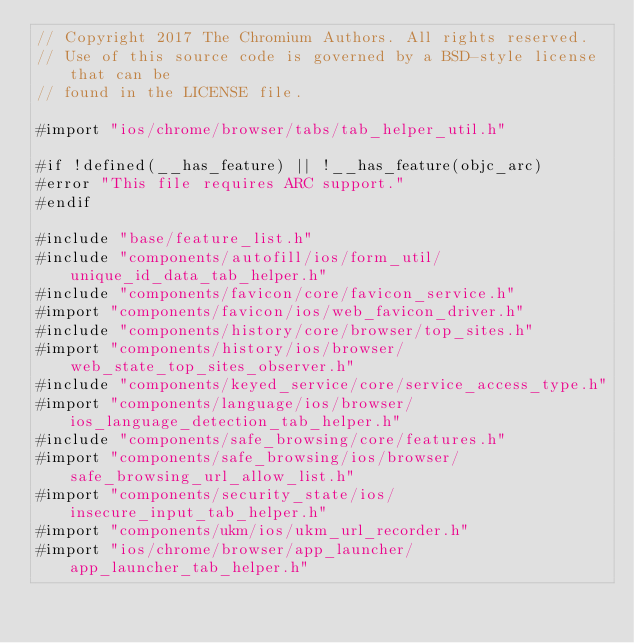Convert code to text. <code><loc_0><loc_0><loc_500><loc_500><_ObjectiveC_>// Copyright 2017 The Chromium Authors. All rights reserved.
// Use of this source code is governed by a BSD-style license that can be
// found in the LICENSE file.

#import "ios/chrome/browser/tabs/tab_helper_util.h"

#if !defined(__has_feature) || !__has_feature(objc_arc)
#error "This file requires ARC support."
#endif

#include "base/feature_list.h"
#include "components/autofill/ios/form_util/unique_id_data_tab_helper.h"
#include "components/favicon/core/favicon_service.h"
#import "components/favicon/ios/web_favicon_driver.h"
#include "components/history/core/browser/top_sites.h"
#import "components/history/ios/browser/web_state_top_sites_observer.h"
#include "components/keyed_service/core/service_access_type.h"
#import "components/language/ios/browser/ios_language_detection_tab_helper.h"
#include "components/safe_browsing/core/features.h"
#import "components/safe_browsing/ios/browser/safe_browsing_url_allow_list.h"
#import "components/security_state/ios/insecure_input_tab_helper.h"
#import "components/ukm/ios/ukm_url_recorder.h"
#import "ios/chrome/browser/app_launcher/app_launcher_tab_helper.h"</code> 